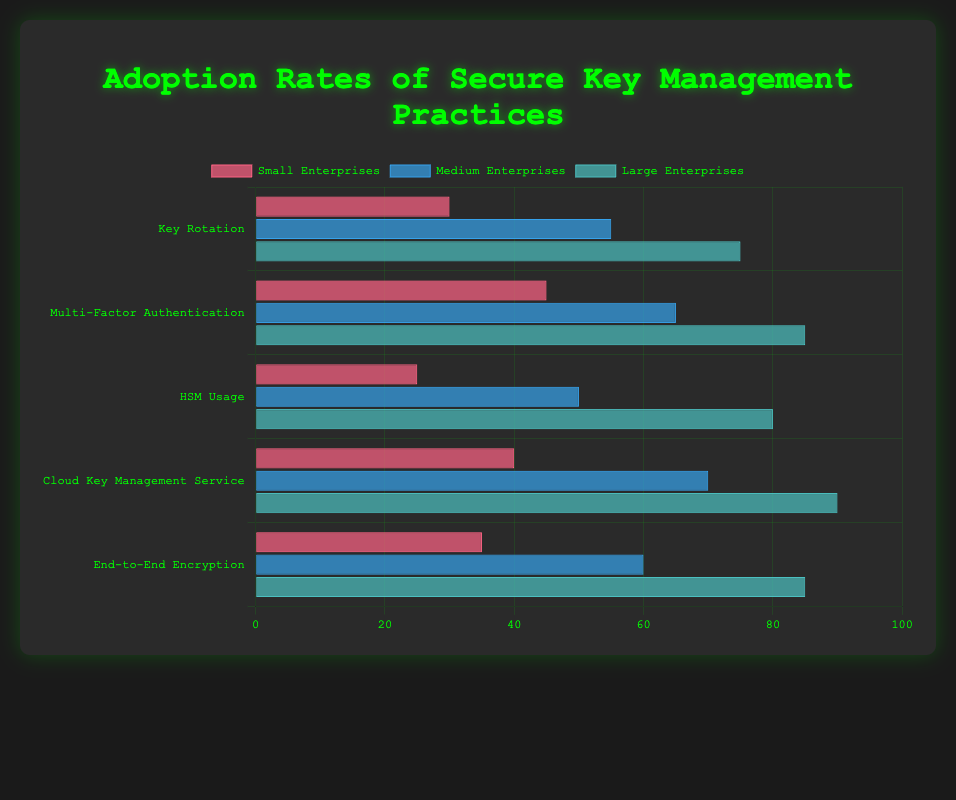What's the adoption rate of Cloud Key Management Service for Medium Enterprises? Cloud Key Management Service for Medium Enterprises is represented by one of the bars in the horizontal chart. Check the height of the bar corresponding to this service under the Medium Enterprises group.
Answer: 70 Which practice has the highest adoption rate among Large Enterprises? Large Enterprises are represented by a dataset, and each practice has a different bar height. The tallest bar indicates the highest adoption rate among practices for Large Enterprises.
Answer: Cloud Key Management Service How much higher is the adoption rate of Multi-Factor Authentication in Large Enterprises compared to Small Enterprises? Find the adoption rates of Multi-Factor Authentication for both Large Enterprises and Small Enterprises. Subtract the rate for Small Enterprises from the rate for Large Enterprises: 85 - 45 = 40.
Answer: 40 Which enterprise group has the lowest adoption rate of HSM Usage, and what is the rate? Look at the heights of the bars for HSM Usage across all three enterprise groups. The shortest bar corresponds to the lowest adoption rate, which is for Small Enterprises.
Answer: Small Enterprises, 25 Compare the adoption rates of Key Rotation between Small and Medium Enterprises. Which has a higher rate and by how much? Find the bars corresponding to Key Rotation for both Small and Medium Enterprises. The rates are 30 for Small Enterprises and 55 for Medium Enterprises. Subtract the smaller rate from the larger: 55 - 30 = 25.
Answer: Medium Enterprises, 25 What's the average adoption rate of End-to-End Encryption for all enterprises? Add the adoption rates for End-to-End Encryption across Small, Medium, and Large Enterprises: 35 + 60 + 85 = 180. Divide by the number of groups (3): 180 / 3 = 60.
Answer: 60 Which secure key management practice shows the least variation in adoption rates across different enterprise sizes? Calculate the range (the difference between the largest and smallest values) for each practice. The smallest range indicates the least variation.
Answer: End-to-End Encryption What percentage of Large Enterprises use HSMs? Locate the bar for HSM Usage under Large Enterprises and read the height.
Answer: 80% Comparing Small and Large Enterprises, which has a greater difference between the adoption rates of Cloud Key Management Service and Key Rotation? For Small Enterprises: Cloud Key Management Service (40) - Key Rotation (30) = 10. For Large Enterprises: Cloud Key Management Service (90) - Key Rotation (75) = 15. Large Enterprises have a greater difference of 15.
Answer: Large Enterprises Which secure key management practice has the highest overall adoption rate when combining all enterprise sizes? Compare the sum of the adoption rates of each practice across Small, Medium, and Large Enterprises. The practice with the highest sum has the highest overall adoption rate. For each practice: 
Key Rotation: 30 + 55 + 75 = 160
Multi-Factor Authentication: 45 + 65 + 85 = 195
HSM Usage: 25 + 50 + 80 = 155
Cloud Key Management Service: 40 + 70 + 90 = 200
End-To-End Encryption: 35 + 60 + 85 = 180.
Cloud Key Management Service has the highest sum of 200.
Answer: Cloud Key Management Service 